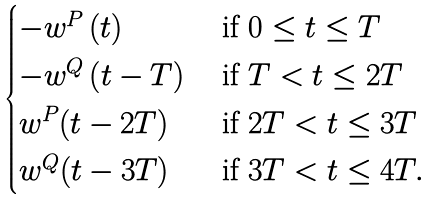Convert formula to latex. <formula><loc_0><loc_0><loc_500><loc_500>\begin{cases} - w ^ { P } \left ( t \right ) & \text { if } 0 \leq t \leq T \\ - w ^ { Q } \left ( t - T \right ) & \text { if } T < t \leq 2 T \\ w ^ { P } ( t - 2 T ) & \text { if } 2 T < t \leq 3 T \\ w ^ { Q } ( t - 3 T ) & \text { if } 3 T < t \leq 4 T . \\ \end{cases}</formula> 